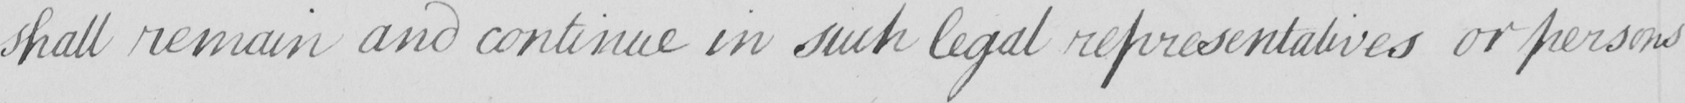Can you tell me what this handwritten text says? shall remain and continue in such legal representatives or persons 